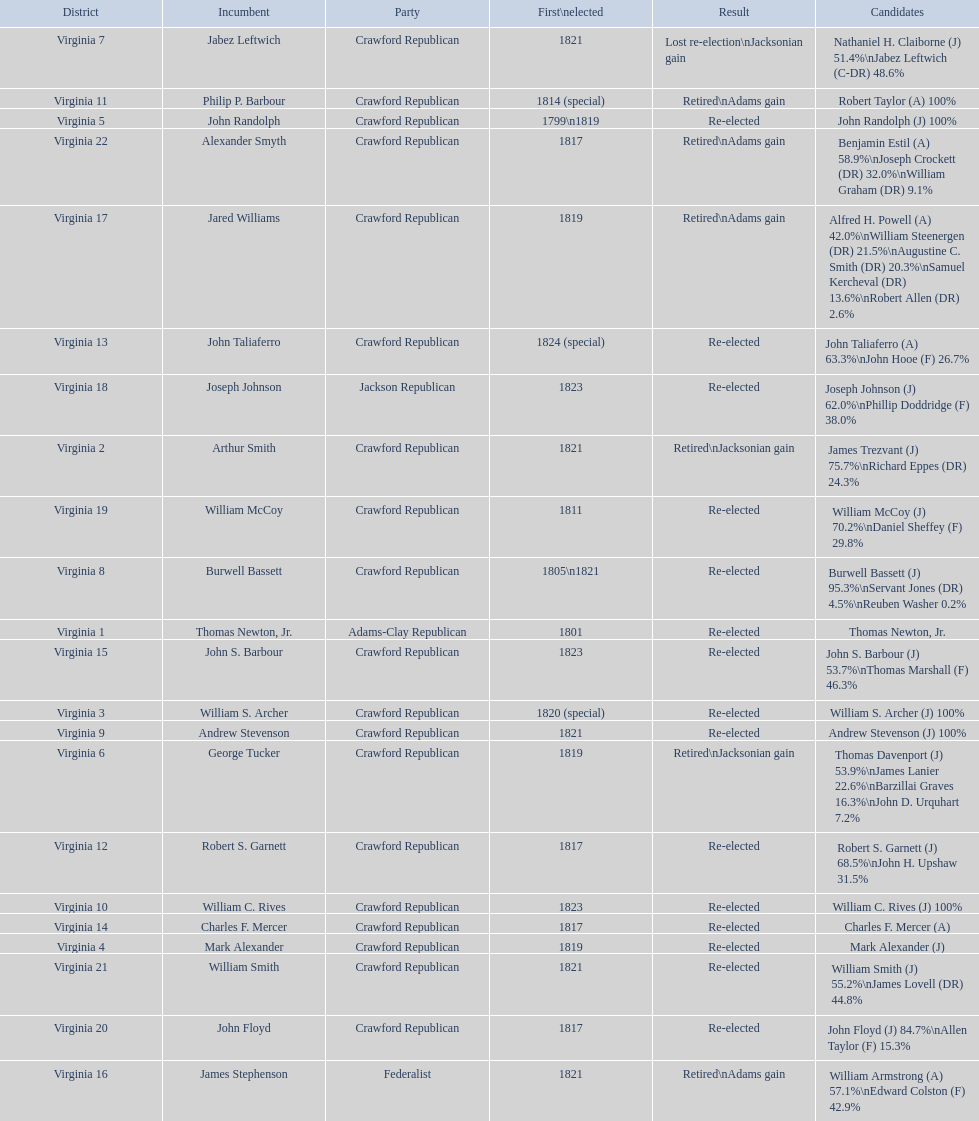What is the last party on this chart? Crawford Republican. 